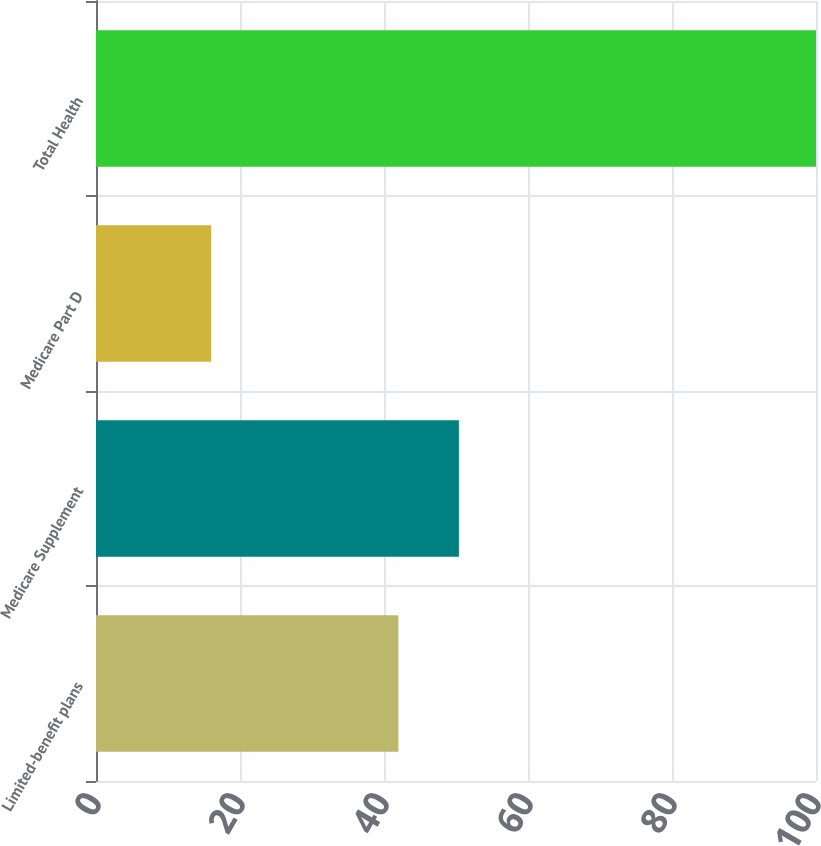Convert chart. <chart><loc_0><loc_0><loc_500><loc_500><bar_chart><fcel>Limited-benefit plans<fcel>Medicare Supplement<fcel>Medicare Part D<fcel>Total Health<nl><fcel>42<fcel>50.4<fcel>16<fcel>100<nl></chart> 